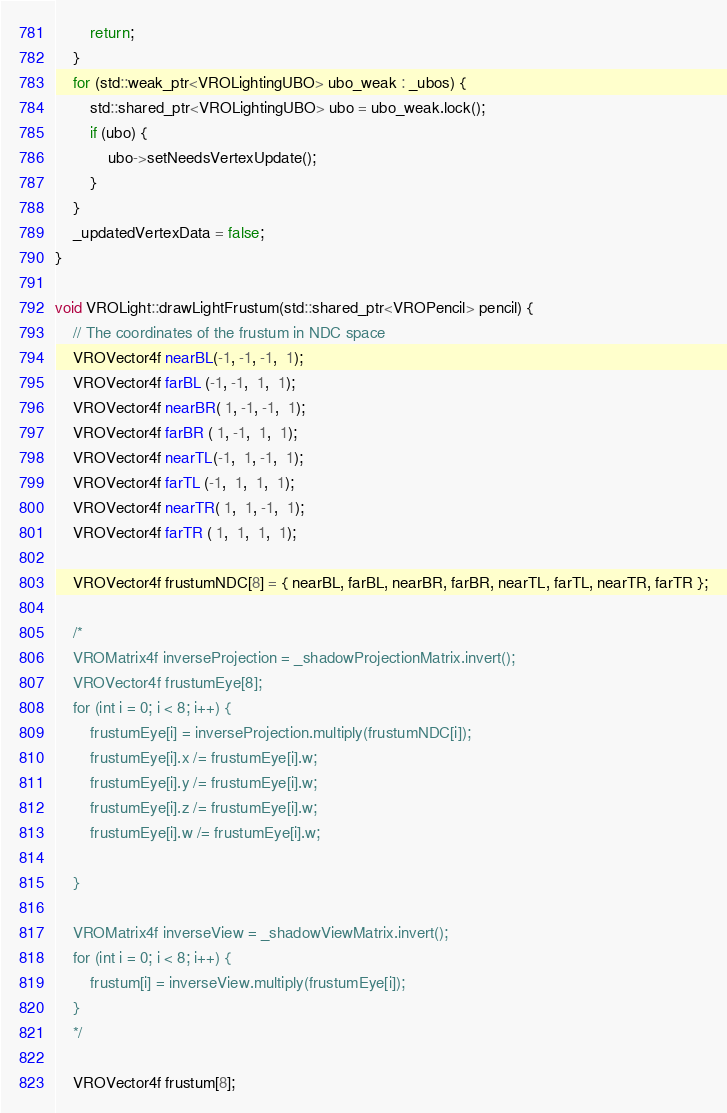<code> <loc_0><loc_0><loc_500><loc_500><_C++_>        return;
    }
    for (std::weak_ptr<VROLightingUBO> ubo_weak : _ubos) {
        std::shared_ptr<VROLightingUBO> ubo = ubo_weak.lock();
        if (ubo) {
            ubo->setNeedsVertexUpdate();
        }
    }
    _updatedVertexData = false;
}

void VROLight::drawLightFrustum(std::shared_ptr<VROPencil> pencil) {
    // The coordinates of the frustum in NDC space
    VROVector4f nearBL(-1, -1, -1,  1);
    VROVector4f farBL (-1, -1,  1,  1);
    VROVector4f nearBR( 1, -1, -1,  1);
    VROVector4f farBR ( 1, -1,  1,  1);
    VROVector4f nearTL(-1,  1, -1,  1);
    VROVector4f farTL (-1,  1,  1,  1);
    VROVector4f nearTR( 1,  1, -1,  1);
    VROVector4f farTR ( 1,  1,  1,  1);
    
    VROVector4f frustumNDC[8] = { nearBL, farBL, nearBR, farBR, nearTL, farTL, nearTR, farTR };
    
    /*
    VROMatrix4f inverseProjection = _shadowProjectionMatrix.invert();
    VROVector4f frustumEye[8];
    for (int i = 0; i < 8; i++) {
        frustumEye[i] = inverseProjection.multiply(frustumNDC[i]);
        frustumEye[i].x /= frustumEye[i].w;
        frustumEye[i].y /= frustumEye[i].w;
        frustumEye[i].z /= frustumEye[i].w;
        frustumEye[i].w /= frustumEye[i].w;
        
    }
    
    VROMatrix4f inverseView = _shadowViewMatrix.invert();
    for (int i = 0; i < 8; i++) {
        frustum[i] = inverseView.multiply(frustumEye[i]);
    }
    */
    
    VROVector4f frustum[8];</code> 